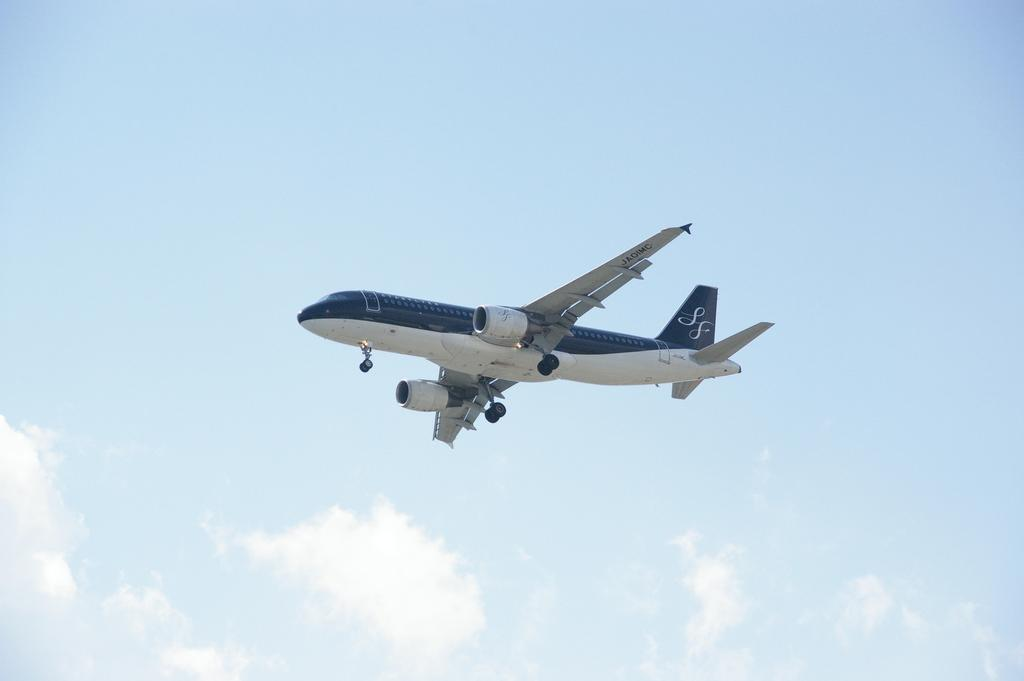What is the main subject of the picture? The main subject of the picture is a passenger plane. What is the plane doing in the image? The plane is flying in the sky. What can be seen at the bottom of the image? The sky is visible at the bottom of the image. What is the condition of the sky in the picture? The sky has clouds present in it. What type of division can be seen in the image? There is no division present in the image; it features a passenger plane flying in the sky with clouds in the background. What kind of collar is visible on the plane in the image? There is no collar present on the plane in the image; it is a typical passenger plane. 